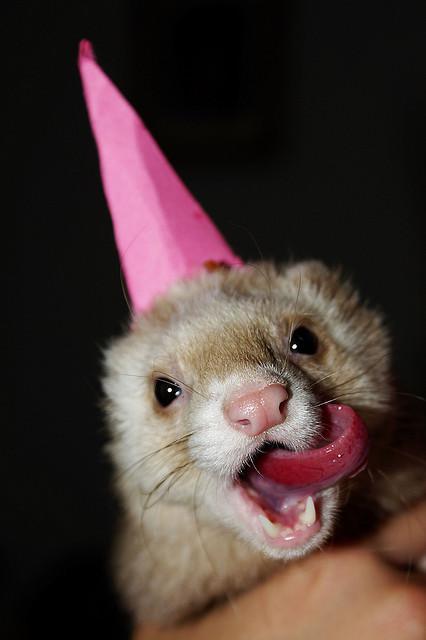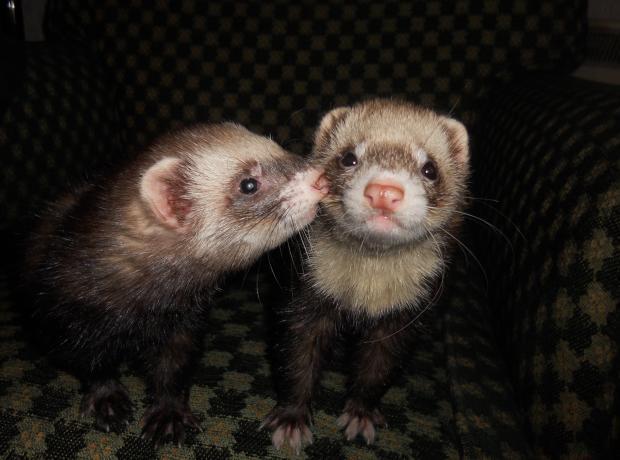The first image is the image on the left, the second image is the image on the right. Assess this claim about the two images: "A ferret with extended tongue is visible.". Correct or not? Answer yes or no. Yes. The first image is the image on the left, the second image is the image on the right. For the images displayed, is the sentence "Two ferrets have their mouths open." factually correct? Answer yes or no. No. 